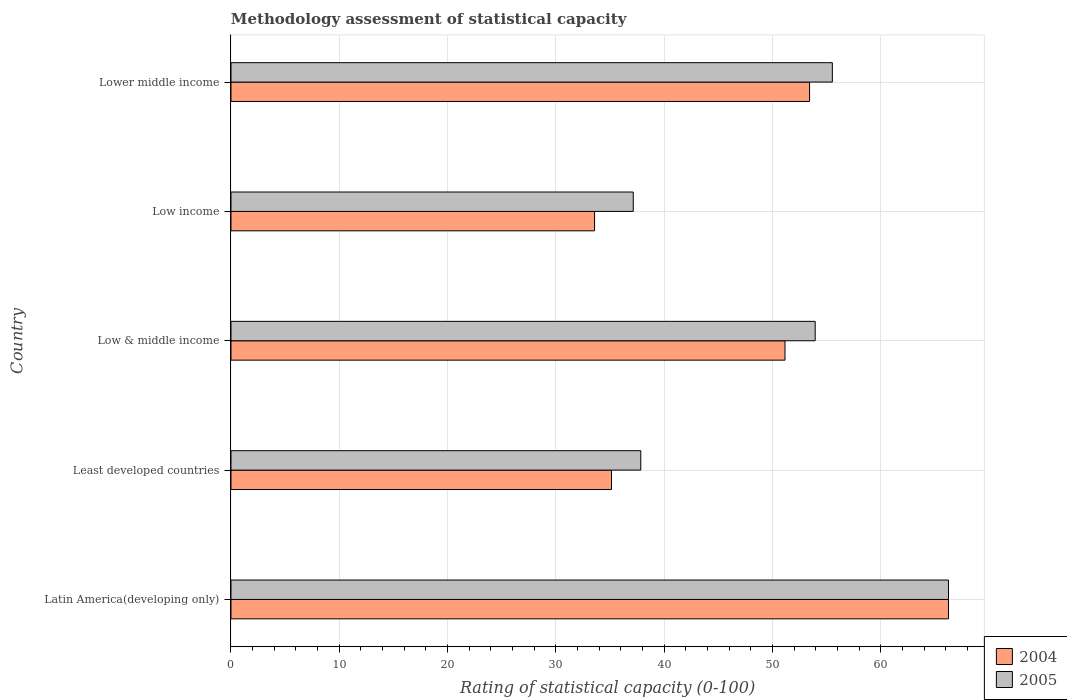How many groups of bars are there?
Provide a succinct answer. 5. How many bars are there on the 2nd tick from the top?
Provide a succinct answer. 2. How many bars are there on the 2nd tick from the bottom?
Provide a short and direct response. 2. What is the label of the 4th group of bars from the top?
Offer a terse response. Least developed countries. In how many cases, is the number of bars for a given country not equal to the number of legend labels?
Offer a terse response. 0. What is the rating of statistical capacity in 2004 in Low & middle income?
Provide a succinct answer. 51.15. Across all countries, what is the maximum rating of statistical capacity in 2005?
Your answer should be very brief. 66.25. Across all countries, what is the minimum rating of statistical capacity in 2005?
Ensure brevity in your answer.  37.14. In which country was the rating of statistical capacity in 2005 maximum?
Your response must be concise. Latin America(developing only). In which country was the rating of statistical capacity in 2004 minimum?
Offer a very short reply. Low income. What is the total rating of statistical capacity in 2004 in the graph?
Your answer should be very brief. 239.53. What is the difference between the rating of statistical capacity in 2005 in Latin America(developing only) and that in Low income?
Offer a very short reply. 29.11. What is the difference between the rating of statistical capacity in 2005 in Low income and the rating of statistical capacity in 2004 in Low & middle income?
Give a very brief answer. -14.01. What is the average rating of statistical capacity in 2004 per country?
Your answer should be very brief. 47.91. What is the difference between the rating of statistical capacity in 2004 and rating of statistical capacity in 2005 in Least developed countries?
Offer a very short reply. -2.7. In how many countries, is the rating of statistical capacity in 2005 greater than 50 ?
Your answer should be very brief. 3. What is the ratio of the rating of statistical capacity in 2004 in Low & middle income to that in Low income?
Your answer should be very brief. 1.52. Is the rating of statistical capacity in 2004 in Least developed countries less than that in Low & middle income?
Your response must be concise. Yes. Is the difference between the rating of statistical capacity in 2004 in Low income and Lower middle income greater than the difference between the rating of statistical capacity in 2005 in Low income and Lower middle income?
Keep it short and to the point. No. What is the difference between the highest and the second highest rating of statistical capacity in 2004?
Your response must be concise. 12.83. What is the difference between the highest and the lowest rating of statistical capacity in 2005?
Your response must be concise. 29.11. In how many countries, is the rating of statistical capacity in 2005 greater than the average rating of statistical capacity in 2005 taken over all countries?
Offer a very short reply. 3. What does the 2nd bar from the top in Lower middle income represents?
Your response must be concise. 2004. What does the 2nd bar from the bottom in Least developed countries represents?
Your answer should be compact. 2005. How many bars are there?
Offer a terse response. 10. What is the difference between two consecutive major ticks on the X-axis?
Provide a short and direct response. 10. Are the values on the major ticks of X-axis written in scientific E-notation?
Offer a very short reply. No. Does the graph contain any zero values?
Offer a very short reply. No. How many legend labels are there?
Keep it short and to the point. 2. What is the title of the graph?
Your response must be concise. Methodology assessment of statistical capacity. Does "1978" appear as one of the legend labels in the graph?
Give a very brief answer. No. What is the label or title of the X-axis?
Make the answer very short. Rating of statistical capacity (0-100). What is the Rating of statistical capacity (0-100) in 2004 in Latin America(developing only)?
Provide a succinct answer. 66.25. What is the Rating of statistical capacity (0-100) in 2005 in Latin America(developing only)?
Offer a very short reply. 66.25. What is the Rating of statistical capacity (0-100) of 2004 in Least developed countries?
Ensure brevity in your answer.  35.14. What is the Rating of statistical capacity (0-100) of 2005 in Least developed countries?
Your answer should be very brief. 37.84. What is the Rating of statistical capacity (0-100) of 2004 in Low & middle income?
Your response must be concise. 51.15. What is the Rating of statistical capacity (0-100) in 2005 in Low & middle income?
Provide a short and direct response. 53.94. What is the Rating of statistical capacity (0-100) of 2004 in Low income?
Your response must be concise. 33.57. What is the Rating of statistical capacity (0-100) of 2005 in Low income?
Ensure brevity in your answer.  37.14. What is the Rating of statistical capacity (0-100) of 2004 in Lower middle income?
Your response must be concise. 53.42. What is the Rating of statistical capacity (0-100) of 2005 in Lower middle income?
Offer a terse response. 55.53. Across all countries, what is the maximum Rating of statistical capacity (0-100) in 2004?
Make the answer very short. 66.25. Across all countries, what is the maximum Rating of statistical capacity (0-100) of 2005?
Your answer should be compact. 66.25. Across all countries, what is the minimum Rating of statistical capacity (0-100) in 2004?
Provide a succinct answer. 33.57. Across all countries, what is the minimum Rating of statistical capacity (0-100) in 2005?
Provide a succinct answer. 37.14. What is the total Rating of statistical capacity (0-100) of 2004 in the graph?
Your answer should be very brief. 239.53. What is the total Rating of statistical capacity (0-100) in 2005 in the graph?
Your answer should be compact. 250.7. What is the difference between the Rating of statistical capacity (0-100) of 2004 in Latin America(developing only) and that in Least developed countries?
Offer a very short reply. 31.11. What is the difference between the Rating of statistical capacity (0-100) in 2005 in Latin America(developing only) and that in Least developed countries?
Keep it short and to the point. 28.41. What is the difference between the Rating of statistical capacity (0-100) of 2004 in Latin America(developing only) and that in Low & middle income?
Offer a very short reply. 15.1. What is the difference between the Rating of statistical capacity (0-100) in 2005 in Latin America(developing only) and that in Low & middle income?
Your answer should be compact. 12.31. What is the difference between the Rating of statistical capacity (0-100) of 2004 in Latin America(developing only) and that in Low income?
Keep it short and to the point. 32.68. What is the difference between the Rating of statistical capacity (0-100) of 2005 in Latin America(developing only) and that in Low income?
Provide a succinct answer. 29.11. What is the difference between the Rating of statistical capacity (0-100) of 2004 in Latin America(developing only) and that in Lower middle income?
Ensure brevity in your answer.  12.83. What is the difference between the Rating of statistical capacity (0-100) in 2005 in Latin America(developing only) and that in Lower middle income?
Ensure brevity in your answer.  10.72. What is the difference between the Rating of statistical capacity (0-100) of 2004 in Least developed countries and that in Low & middle income?
Make the answer very short. -16.02. What is the difference between the Rating of statistical capacity (0-100) in 2005 in Least developed countries and that in Low & middle income?
Give a very brief answer. -16.1. What is the difference between the Rating of statistical capacity (0-100) of 2004 in Least developed countries and that in Low income?
Provide a short and direct response. 1.56. What is the difference between the Rating of statistical capacity (0-100) in 2005 in Least developed countries and that in Low income?
Provide a short and direct response. 0.69. What is the difference between the Rating of statistical capacity (0-100) of 2004 in Least developed countries and that in Lower middle income?
Your answer should be compact. -18.29. What is the difference between the Rating of statistical capacity (0-100) of 2005 in Least developed countries and that in Lower middle income?
Your response must be concise. -17.69. What is the difference between the Rating of statistical capacity (0-100) in 2004 in Low & middle income and that in Low income?
Provide a succinct answer. 17.58. What is the difference between the Rating of statistical capacity (0-100) of 2005 in Low & middle income and that in Low income?
Offer a very short reply. 16.8. What is the difference between the Rating of statistical capacity (0-100) of 2004 in Low & middle income and that in Lower middle income?
Offer a terse response. -2.27. What is the difference between the Rating of statistical capacity (0-100) in 2005 in Low & middle income and that in Lower middle income?
Give a very brief answer. -1.58. What is the difference between the Rating of statistical capacity (0-100) of 2004 in Low income and that in Lower middle income?
Provide a short and direct response. -19.85. What is the difference between the Rating of statistical capacity (0-100) of 2005 in Low income and that in Lower middle income?
Offer a very short reply. -18.38. What is the difference between the Rating of statistical capacity (0-100) of 2004 in Latin America(developing only) and the Rating of statistical capacity (0-100) of 2005 in Least developed countries?
Ensure brevity in your answer.  28.41. What is the difference between the Rating of statistical capacity (0-100) in 2004 in Latin America(developing only) and the Rating of statistical capacity (0-100) in 2005 in Low & middle income?
Provide a succinct answer. 12.31. What is the difference between the Rating of statistical capacity (0-100) in 2004 in Latin America(developing only) and the Rating of statistical capacity (0-100) in 2005 in Low income?
Offer a terse response. 29.11. What is the difference between the Rating of statistical capacity (0-100) of 2004 in Latin America(developing only) and the Rating of statistical capacity (0-100) of 2005 in Lower middle income?
Keep it short and to the point. 10.72. What is the difference between the Rating of statistical capacity (0-100) in 2004 in Least developed countries and the Rating of statistical capacity (0-100) in 2005 in Low & middle income?
Keep it short and to the point. -18.81. What is the difference between the Rating of statistical capacity (0-100) in 2004 in Least developed countries and the Rating of statistical capacity (0-100) in 2005 in Low income?
Keep it short and to the point. -2.01. What is the difference between the Rating of statistical capacity (0-100) in 2004 in Least developed countries and the Rating of statistical capacity (0-100) in 2005 in Lower middle income?
Your answer should be very brief. -20.39. What is the difference between the Rating of statistical capacity (0-100) of 2004 in Low & middle income and the Rating of statistical capacity (0-100) of 2005 in Low income?
Your answer should be very brief. 14.01. What is the difference between the Rating of statistical capacity (0-100) in 2004 in Low & middle income and the Rating of statistical capacity (0-100) in 2005 in Lower middle income?
Make the answer very short. -4.37. What is the difference between the Rating of statistical capacity (0-100) of 2004 in Low income and the Rating of statistical capacity (0-100) of 2005 in Lower middle income?
Give a very brief answer. -21.95. What is the average Rating of statistical capacity (0-100) of 2004 per country?
Your response must be concise. 47.91. What is the average Rating of statistical capacity (0-100) in 2005 per country?
Make the answer very short. 50.14. What is the difference between the Rating of statistical capacity (0-100) in 2004 and Rating of statistical capacity (0-100) in 2005 in Least developed countries?
Give a very brief answer. -2.7. What is the difference between the Rating of statistical capacity (0-100) of 2004 and Rating of statistical capacity (0-100) of 2005 in Low & middle income?
Your answer should be compact. -2.79. What is the difference between the Rating of statistical capacity (0-100) in 2004 and Rating of statistical capacity (0-100) in 2005 in Low income?
Your answer should be very brief. -3.57. What is the difference between the Rating of statistical capacity (0-100) of 2004 and Rating of statistical capacity (0-100) of 2005 in Lower middle income?
Your answer should be compact. -2.11. What is the ratio of the Rating of statistical capacity (0-100) of 2004 in Latin America(developing only) to that in Least developed countries?
Ensure brevity in your answer.  1.89. What is the ratio of the Rating of statistical capacity (0-100) in 2005 in Latin America(developing only) to that in Least developed countries?
Your answer should be compact. 1.75. What is the ratio of the Rating of statistical capacity (0-100) of 2004 in Latin America(developing only) to that in Low & middle income?
Make the answer very short. 1.3. What is the ratio of the Rating of statistical capacity (0-100) of 2005 in Latin America(developing only) to that in Low & middle income?
Provide a succinct answer. 1.23. What is the ratio of the Rating of statistical capacity (0-100) of 2004 in Latin America(developing only) to that in Low income?
Make the answer very short. 1.97. What is the ratio of the Rating of statistical capacity (0-100) in 2005 in Latin America(developing only) to that in Low income?
Keep it short and to the point. 1.78. What is the ratio of the Rating of statistical capacity (0-100) of 2004 in Latin America(developing only) to that in Lower middle income?
Offer a terse response. 1.24. What is the ratio of the Rating of statistical capacity (0-100) of 2005 in Latin America(developing only) to that in Lower middle income?
Give a very brief answer. 1.19. What is the ratio of the Rating of statistical capacity (0-100) of 2004 in Least developed countries to that in Low & middle income?
Give a very brief answer. 0.69. What is the ratio of the Rating of statistical capacity (0-100) of 2005 in Least developed countries to that in Low & middle income?
Your answer should be compact. 0.7. What is the ratio of the Rating of statistical capacity (0-100) in 2004 in Least developed countries to that in Low income?
Provide a succinct answer. 1.05. What is the ratio of the Rating of statistical capacity (0-100) in 2005 in Least developed countries to that in Low income?
Keep it short and to the point. 1.02. What is the ratio of the Rating of statistical capacity (0-100) of 2004 in Least developed countries to that in Lower middle income?
Provide a short and direct response. 0.66. What is the ratio of the Rating of statistical capacity (0-100) of 2005 in Least developed countries to that in Lower middle income?
Offer a terse response. 0.68. What is the ratio of the Rating of statistical capacity (0-100) in 2004 in Low & middle income to that in Low income?
Provide a succinct answer. 1.52. What is the ratio of the Rating of statistical capacity (0-100) in 2005 in Low & middle income to that in Low income?
Keep it short and to the point. 1.45. What is the ratio of the Rating of statistical capacity (0-100) in 2004 in Low & middle income to that in Lower middle income?
Offer a very short reply. 0.96. What is the ratio of the Rating of statistical capacity (0-100) in 2005 in Low & middle income to that in Lower middle income?
Offer a terse response. 0.97. What is the ratio of the Rating of statistical capacity (0-100) of 2004 in Low income to that in Lower middle income?
Provide a succinct answer. 0.63. What is the ratio of the Rating of statistical capacity (0-100) of 2005 in Low income to that in Lower middle income?
Provide a succinct answer. 0.67. What is the difference between the highest and the second highest Rating of statistical capacity (0-100) of 2004?
Make the answer very short. 12.83. What is the difference between the highest and the second highest Rating of statistical capacity (0-100) in 2005?
Give a very brief answer. 10.72. What is the difference between the highest and the lowest Rating of statistical capacity (0-100) of 2004?
Offer a very short reply. 32.68. What is the difference between the highest and the lowest Rating of statistical capacity (0-100) in 2005?
Make the answer very short. 29.11. 